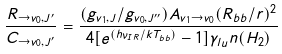<formula> <loc_0><loc_0><loc_500><loc_500>\frac { R _ { \rightarrow v _ { 0 } , J ^ { \prime } } } { C _ { \rightarrow v _ { 0 } , J ^ { \prime } } } = \frac { ( g _ { v _ { 1 } , J } / g _ { v _ { 0 } , J ^ { \prime \prime } } ) A _ { v _ { 1 } \rightarrow v _ { 0 } } ( R _ { b b } / r ) ^ { 2 } } { 4 [ e ^ { ( h \nu _ { I R } / k T _ { b b } ) } - 1 ] \gamma _ { l u } n ( H _ { 2 } ) }</formula> 